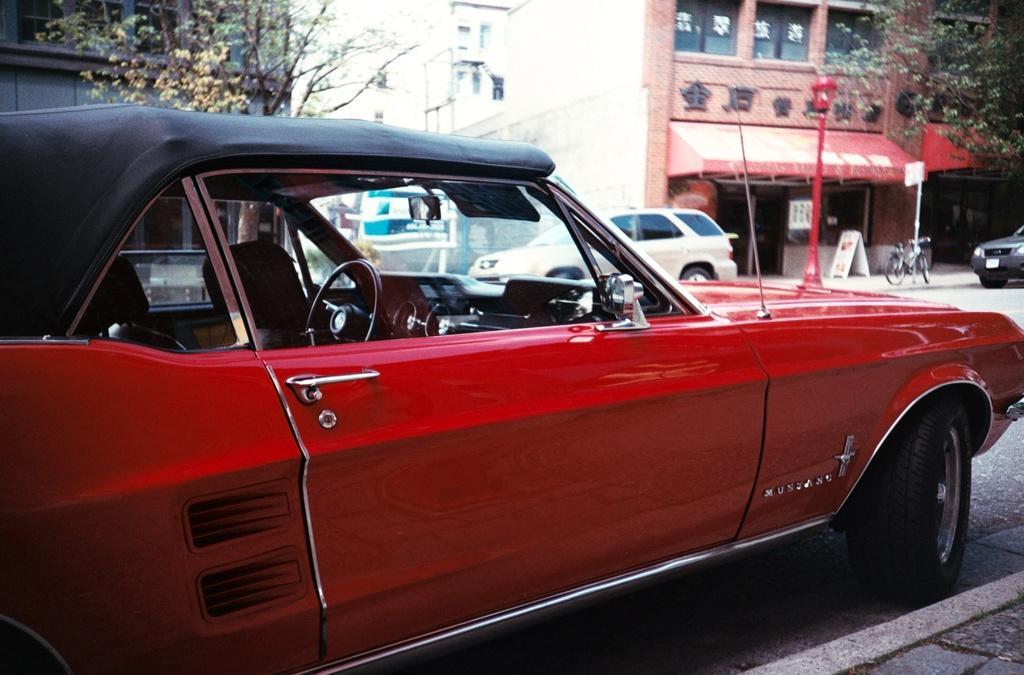Can you describe this image briefly? In this image we can see group of vehicles parked on the road. IN the background we can see trees, buildings ,pole. 